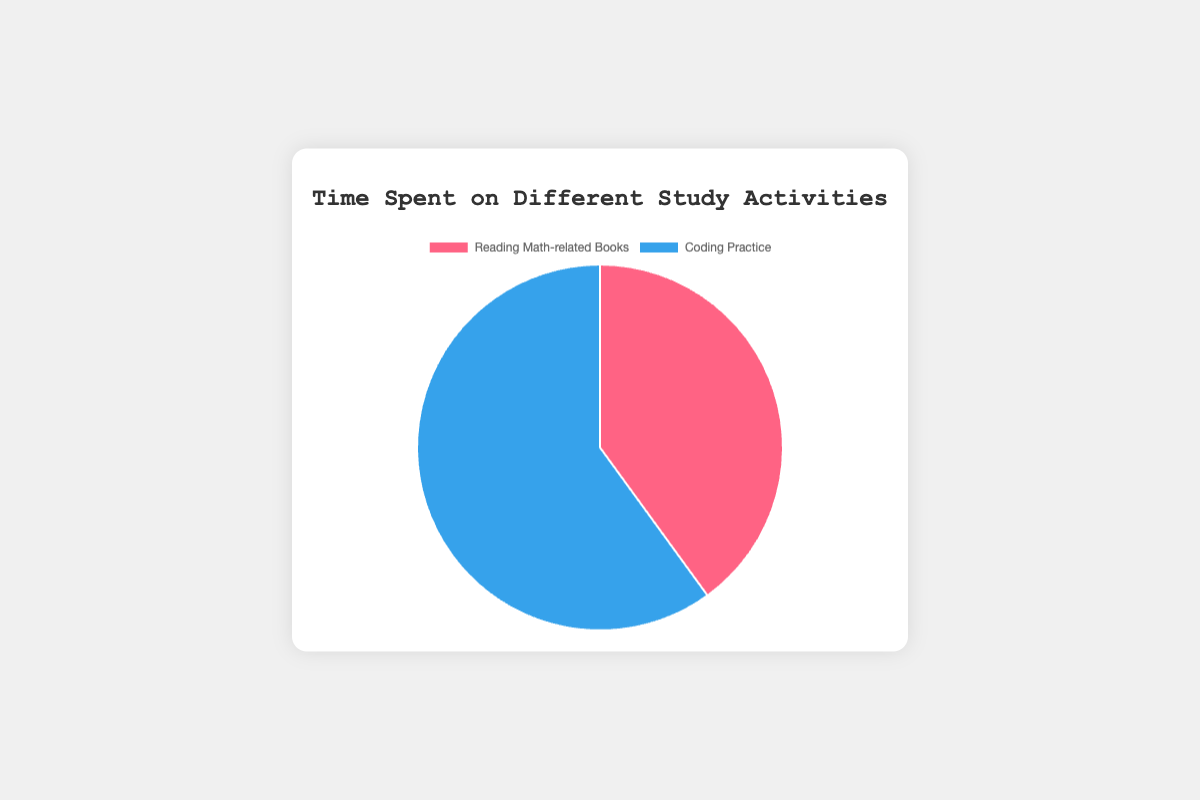What is the total time spent on both activities combined? To find the total time spent on both activities, sum the hours spent on "Reading Math-related Books" and "Coding Practice": 12 (Reading) + 18 (Coding) = 30 hours.
Answer: 30 hours Which activity took more time, and by how many hours? Compare the hours spent on each activity: 18 (Coding) - 12 (Reading) = 6 hours more for Coding Practice.
Answer: Coding Practice by 6 hours What percentage of total study time is spent on Reading Math-related Books? To find the percentage, divide the hours spent on Reading by the total hours and multiply by 100: (12 / 30) * 100 = 40%.
Answer: 40% What is the ratio of time spent on Coding Practice to Reading Math-related Books? The ratio of Coding Practice hours to Reading hours is 18:12. Simplify this ratio by dividing both sides by their greatest common divisor (6): 18 ÷ 6 : 12 ÷ 6 = 3:2.
Answer: 3:2 If 2 hours are moved from Coding Practice to Reading Math-related Books, what will be the new time distribution? Subtract 2 hours from Coding and add 2 hours to Reading: Reading Math-related Books = 12 + 2 = 14 hours, Coding Practice = 18 - 2 = 16 hours.
Answer: Reading: 14 hours, Coding: 16 hours Which section of the pie chart is larger, and how can you visually identify it? The section representing "Coding Practice" is larger. This can be visually identified because it occupies a larger arc in the pie chart compared to "Reading Math-related Books".
Answer: Coding Practice How much more time is spent on Coding Practice compared to any one of the Math-related Books individually? Compare time spent on Coding Practice (18 hours) with the highest time spent on a single Math-related book, which is "Fermat's Enigma" at 5 hours. The additional time is 18 - 5 = 13 hours.
Answer: 13 hours What fraction of time is spent on Coding Practice? Divide the time spent on Coding Practice by the total study time: 18 / 30 = 3/5.
Answer: 3/5 